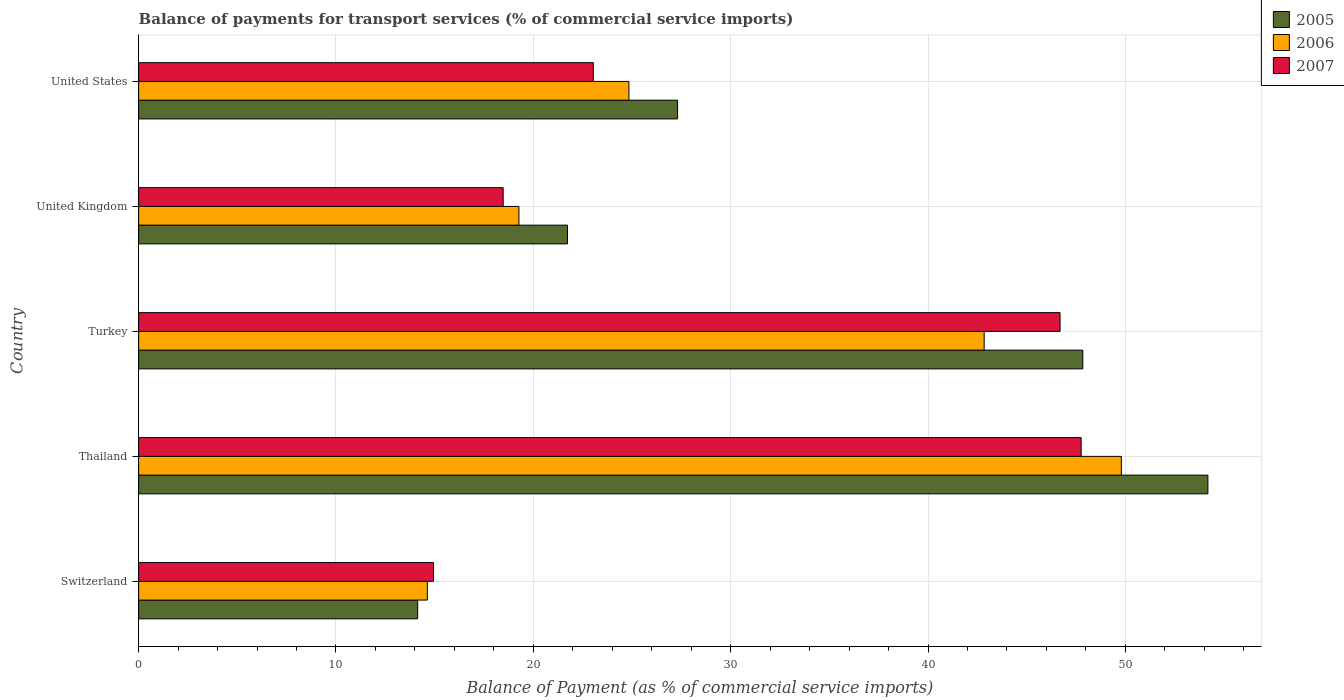How many different coloured bars are there?
Ensure brevity in your answer.  3. How many groups of bars are there?
Offer a very short reply. 5. Are the number of bars per tick equal to the number of legend labels?
Give a very brief answer. Yes. How many bars are there on the 2nd tick from the top?
Provide a succinct answer. 3. What is the label of the 4th group of bars from the top?
Ensure brevity in your answer.  Thailand. In how many cases, is the number of bars for a given country not equal to the number of legend labels?
Provide a short and direct response. 0. What is the balance of payments for transport services in 2005 in United States?
Your answer should be compact. 27.31. Across all countries, what is the maximum balance of payments for transport services in 2005?
Ensure brevity in your answer.  54.18. Across all countries, what is the minimum balance of payments for transport services in 2006?
Ensure brevity in your answer.  14.63. In which country was the balance of payments for transport services in 2006 maximum?
Provide a succinct answer. Thailand. In which country was the balance of payments for transport services in 2006 minimum?
Provide a short and direct response. Switzerland. What is the total balance of payments for transport services in 2005 in the graph?
Ensure brevity in your answer.  165.2. What is the difference between the balance of payments for transport services in 2005 in Thailand and that in United States?
Your answer should be compact. 26.87. What is the difference between the balance of payments for transport services in 2005 in United Kingdom and the balance of payments for transport services in 2007 in United States?
Your response must be concise. -1.31. What is the average balance of payments for transport services in 2005 per country?
Offer a terse response. 33.04. What is the difference between the balance of payments for transport services in 2005 and balance of payments for transport services in 2007 in United Kingdom?
Keep it short and to the point. 3.26. What is the ratio of the balance of payments for transport services in 2005 in Switzerland to that in United States?
Your answer should be compact. 0.52. Is the balance of payments for transport services in 2007 in Switzerland less than that in Thailand?
Give a very brief answer. Yes. What is the difference between the highest and the second highest balance of payments for transport services in 2006?
Give a very brief answer. 6.95. What is the difference between the highest and the lowest balance of payments for transport services in 2005?
Your answer should be very brief. 40.04. In how many countries, is the balance of payments for transport services in 2006 greater than the average balance of payments for transport services in 2006 taken over all countries?
Offer a very short reply. 2. Is the sum of the balance of payments for transport services in 2006 in Thailand and United States greater than the maximum balance of payments for transport services in 2005 across all countries?
Provide a short and direct response. Yes. What does the 2nd bar from the bottom in Turkey represents?
Provide a short and direct response. 2006. Is it the case that in every country, the sum of the balance of payments for transport services in 2006 and balance of payments for transport services in 2005 is greater than the balance of payments for transport services in 2007?
Make the answer very short. Yes. How many bars are there?
Offer a very short reply. 15. Are all the bars in the graph horizontal?
Offer a terse response. Yes. How many countries are there in the graph?
Ensure brevity in your answer.  5. What is the difference between two consecutive major ticks on the X-axis?
Offer a terse response. 10. Are the values on the major ticks of X-axis written in scientific E-notation?
Keep it short and to the point. No. Where does the legend appear in the graph?
Provide a short and direct response. Top right. How are the legend labels stacked?
Your answer should be very brief. Vertical. What is the title of the graph?
Give a very brief answer. Balance of payments for transport services (% of commercial service imports). What is the label or title of the X-axis?
Your answer should be compact. Balance of Payment (as % of commercial service imports). What is the Balance of Payment (as % of commercial service imports) of 2005 in Switzerland?
Give a very brief answer. 14.14. What is the Balance of Payment (as % of commercial service imports) in 2006 in Switzerland?
Your answer should be very brief. 14.63. What is the Balance of Payment (as % of commercial service imports) in 2007 in Switzerland?
Your answer should be very brief. 14.94. What is the Balance of Payment (as % of commercial service imports) in 2005 in Thailand?
Make the answer very short. 54.18. What is the Balance of Payment (as % of commercial service imports) of 2006 in Thailand?
Provide a short and direct response. 49.79. What is the Balance of Payment (as % of commercial service imports) in 2007 in Thailand?
Provide a short and direct response. 47.76. What is the Balance of Payment (as % of commercial service imports) of 2005 in Turkey?
Your answer should be very brief. 47.84. What is the Balance of Payment (as % of commercial service imports) of 2006 in Turkey?
Your answer should be very brief. 42.84. What is the Balance of Payment (as % of commercial service imports) of 2007 in Turkey?
Keep it short and to the point. 46.69. What is the Balance of Payment (as % of commercial service imports) in 2005 in United Kingdom?
Your answer should be compact. 21.73. What is the Balance of Payment (as % of commercial service imports) of 2006 in United Kingdom?
Your response must be concise. 19.27. What is the Balance of Payment (as % of commercial service imports) of 2007 in United Kingdom?
Your answer should be very brief. 18.47. What is the Balance of Payment (as % of commercial service imports) of 2005 in United States?
Keep it short and to the point. 27.31. What is the Balance of Payment (as % of commercial service imports) of 2006 in United States?
Provide a succinct answer. 24.84. What is the Balance of Payment (as % of commercial service imports) of 2007 in United States?
Ensure brevity in your answer.  23.04. Across all countries, what is the maximum Balance of Payment (as % of commercial service imports) in 2005?
Your answer should be compact. 54.18. Across all countries, what is the maximum Balance of Payment (as % of commercial service imports) of 2006?
Offer a terse response. 49.79. Across all countries, what is the maximum Balance of Payment (as % of commercial service imports) in 2007?
Keep it short and to the point. 47.76. Across all countries, what is the minimum Balance of Payment (as % of commercial service imports) of 2005?
Offer a very short reply. 14.14. Across all countries, what is the minimum Balance of Payment (as % of commercial service imports) of 2006?
Your response must be concise. 14.63. Across all countries, what is the minimum Balance of Payment (as % of commercial service imports) of 2007?
Your answer should be very brief. 14.94. What is the total Balance of Payment (as % of commercial service imports) in 2005 in the graph?
Your answer should be very brief. 165.2. What is the total Balance of Payment (as % of commercial service imports) of 2006 in the graph?
Provide a short and direct response. 151.38. What is the total Balance of Payment (as % of commercial service imports) in 2007 in the graph?
Your response must be concise. 150.9. What is the difference between the Balance of Payment (as % of commercial service imports) in 2005 in Switzerland and that in Thailand?
Provide a short and direct response. -40.04. What is the difference between the Balance of Payment (as % of commercial service imports) of 2006 in Switzerland and that in Thailand?
Keep it short and to the point. -35.17. What is the difference between the Balance of Payment (as % of commercial service imports) in 2007 in Switzerland and that in Thailand?
Ensure brevity in your answer.  -32.82. What is the difference between the Balance of Payment (as % of commercial service imports) of 2005 in Switzerland and that in Turkey?
Offer a terse response. -33.7. What is the difference between the Balance of Payment (as % of commercial service imports) in 2006 in Switzerland and that in Turkey?
Provide a short and direct response. -28.21. What is the difference between the Balance of Payment (as % of commercial service imports) in 2007 in Switzerland and that in Turkey?
Give a very brief answer. -31.75. What is the difference between the Balance of Payment (as % of commercial service imports) of 2005 in Switzerland and that in United Kingdom?
Ensure brevity in your answer.  -7.59. What is the difference between the Balance of Payment (as % of commercial service imports) of 2006 in Switzerland and that in United Kingdom?
Offer a very short reply. -4.64. What is the difference between the Balance of Payment (as % of commercial service imports) in 2007 in Switzerland and that in United Kingdom?
Your response must be concise. -3.53. What is the difference between the Balance of Payment (as % of commercial service imports) of 2005 in Switzerland and that in United States?
Offer a very short reply. -13.17. What is the difference between the Balance of Payment (as % of commercial service imports) of 2006 in Switzerland and that in United States?
Your answer should be very brief. -10.21. What is the difference between the Balance of Payment (as % of commercial service imports) of 2007 in Switzerland and that in United States?
Provide a succinct answer. -8.1. What is the difference between the Balance of Payment (as % of commercial service imports) of 2005 in Thailand and that in Turkey?
Ensure brevity in your answer.  6.34. What is the difference between the Balance of Payment (as % of commercial service imports) in 2006 in Thailand and that in Turkey?
Provide a short and direct response. 6.95. What is the difference between the Balance of Payment (as % of commercial service imports) of 2007 in Thailand and that in Turkey?
Make the answer very short. 1.07. What is the difference between the Balance of Payment (as % of commercial service imports) of 2005 in Thailand and that in United Kingdom?
Your answer should be compact. 32.45. What is the difference between the Balance of Payment (as % of commercial service imports) of 2006 in Thailand and that in United Kingdom?
Offer a terse response. 30.52. What is the difference between the Balance of Payment (as % of commercial service imports) of 2007 in Thailand and that in United Kingdom?
Keep it short and to the point. 29.29. What is the difference between the Balance of Payment (as % of commercial service imports) in 2005 in Thailand and that in United States?
Provide a succinct answer. 26.87. What is the difference between the Balance of Payment (as % of commercial service imports) in 2006 in Thailand and that in United States?
Give a very brief answer. 24.95. What is the difference between the Balance of Payment (as % of commercial service imports) in 2007 in Thailand and that in United States?
Provide a succinct answer. 24.72. What is the difference between the Balance of Payment (as % of commercial service imports) in 2005 in Turkey and that in United Kingdom?
Your answer should be compact. 26.11. What is the difference between the Balance of Payment (as % of commercial service imports) in 2006 in Turkey and that in United Kingdom?
Offer a terse response. 23.57. What is the difference between the Balance of Payment (as % of commercial service imports) of 2007 in Turkey and that in United Kingdom?
Offer a very short reply. 28.22. What is the difference between the Balance of Payment (as % of commercial service imports) in 2005 in Turkey and that in United States?
Ensure brevity in your answer.  20.53. What is the difference between the Balance of Payment (as % of commercial service imports) of 2006 in Turkey and that in United States?
Provide a short and direct response. 18. What is the difference between the Balance of Payment (as % of commercial service imports) in 2007 in Turkey and that in United States?
Make the answer very short. 23.65. What is the difference between the Balance of Payment (as % of commercial service imports) of 2005 in United Kingdom and that in United States?
Your answer should be very brief. -5.58. What is the difference between the Balance of Payment (as % of commercial service imports) in 2006 in United Kingdom and that in United States?
Give a very brief answer. -5.57. What is the difference between the Balance of Payment (as % of commercial service imports) of 2007 in United Kingdom and that in United States?
Offer a terse response. -4.57. What is the difference between the Balance of Payment (as % of commercial service imports) in 2005 in Switzerland and the Balance of Payment (as % of commercial service imports) in 2006 in Thailand?
Your answer should be very brief. -35.66. What is the difference between the Balance of Payment (as % of commercial service imports) of 2005 in Switzerland and the Balance of Payment (as % of commercial service imports) of 2007 in Thailand?
Offer a terse response. -33.62. What is the difference between the Balance of Payment (as % of commercial service imports) in 2006 in Switzerland and the Balance of Payment (as % of commercial service imports) in 2007 in Thailand?
Provide a succinct answer. -33.13. What is the difference between the Balance of Payment (as % of commercial service imports) in 2005 in Switzerland and the Balance of Payment (as % of commercial service imports) in 2006 in Turkey?
Give a very brief answer. -28.7. What is the difference between the Balance of Payment (as % of commercial service imports) in 2005 in Switzerland and the Balance of Payment (as % of commercial service imports) in 2007 in Turkey?
Make the answer very short. -32.55. What is the difference between the Balance of Payment (as % of commercial service imports) of 2006 in Switzerland and the Balance of Payment (as % of commercial service imports) of 2007 in Turkey?
Your answer should be compact. -32.06. What is the difference between the Balance of Payment (as % of commercial service imports) of 2005 in Switzerland and the Balance of Payment (as % of commercial service imports) of 2006 in United Kingdom?
Ensure brevity in your answer.  -5.13. What is the difference between the Balance of Payment (as % of commercial service imports) in 2005 in Switzerland and the Balance of Payment (as % of commercial service imports) in 2007 in United Kingdom?
Provide a short and direct response. -4.33. What is the difference between the Balance of Payment (as % of commercial service imports) in 2006 in Switzerland and the Balance of Payment (as % of commercial service imports) in 2007 in United Kingdom?
Offer a terse response. -3.84. What is the difference between the Balance of Payment (as % of commercial service imports) of 2005 in Switzerland and the Balance of Payment (as % of commercial service imports) of 2006 in United States?
Ensure brevity in your answer.  -10.7. What is the difference between the Balance of Payment (as % of commercial service imports) in 2005 in Switzerland and the Balance of Payment (as % of commercial service imports) in 2007 in United States?
Provide a succinct answer. -8.9. What is the difference between the Balance of Payment (as % of commercial service imports) of 2006 in Switzerland and the Balance of Payment (as % of commercial service imports) of 2007 in United States?
Your answer should be compact. -8.41. What is the difference between the Balance of Payment (as % of commercial service imports) of 2005 in Thailand and the Balance of Payment (as % of commercial service imports) of 2006 in Turkey?
Provide a succinct answer. 11.34. What is the difference between the Balance of Payment (as % of commercial service imports) in 2005 in Thailand and the Balance of Payment (as % of commercial service imports) in 2007 in Turkey?
Your response must be concise. 7.49. What is the difference between the Balance of Payment (as % of commercial service imports) of 2006 in Thailand and the Balance of Payment (as % of commercial service imports) of 2007 in Turkey?
Your answer should be compact. 3.11. What is the difference between the Balance of Payment (as % of commercial service imports) of 2005 in Thailand and the Balance of Payment (as % of commercial service imports) of 2006 in United Kingdom?
Give a very brief answer. 34.91. What is the difference between the Balance of Payment (as % of commercial service imports) in 2005 in Thailand and the Balance of Payment (as % of commercial service imports) in 2007 in United Kingdom?
Ensure brevity in your answer.  35.71. What is the difference between the Balance of Payment (as % of commercial service imports) in 2006 in Thailand and the Balance of Payment (as % of commercial service imports) in 2007 in United Kingdom?
Your response must be concise. 31.32. What is the difference between the Balance of Payment (as % of commercial service imports) of 2005 in Thailand and the Balance of Payment (as % of commercial service imports) of 2006 in United States?
Provide a short and direct response. 29.34. What is the difference between the Balance of Payment (as % of commercial service imports) in 2005 in Thailand and the Balance of Payment (as % of commercial service imports) in 2007 in United States?
Provide a succinct answer. 31.14. What is the difference between the Balance of Payment (as % of commercial service imports) of 2006 in Thailand and the Balance of Payment (as % of commercial service imports) of 2007 in United States?
Ensure brevity in your answer.  26.76. What is the difference between the Balance of Payment (as % of commercial service imports) of 2005 in Turkey and the Balance of Payment (as % of commercial service imports) of 2006 in United Kingdom?
Your response must be concise. 28.57. What is the difference between the Balance of Payment (as % of commercial service imports) in 2005 in Turkey and the Balance of Payment (as % of commercial service imports) in 2007 in United Kingdom?
Give a very brief answer. 29.37. What is the difference between the Balance of Payment (as % of commercial service imports) in 2006 in Turkey and the Balance of Payment (as % of commercial service imports) in 2007 in United Kingdom?
Offer a terse response. 24.37. What is the difference between the Balance of Payment (as % of commercial service imports) in 2005 in Turkey and the Balance of Payment (as % of commercial service imports) in 2006 in United States?
Ensure brevity in your answer.  23. What is the difference between the Balance of Payment (as % of commercial service imports) of 2005 in Turkey and the Balance of Payment (as % of commercial service imports) of 2007 in United States?
Keep it short and to the point. 24.8. What is the difference between the Balance of Payment (as % of commercial service imports) in 2006 in Turkey and the Balance of Payment (as % of commercial service imports) in 2007 in United States?
Offer a terse response. 19.8. What is the difference between the Balance of Payment (as % of commercial service imports) in 2005 in United Kingdom and the Balance of Payment (as % of commercial service imports) in 2006 in United States?
Your response must be concise. -3.11. What is the difference between the Balance of Payment (as % of commercial service imports) in 2005 in United Kingdom and the Balance of Payment (as % of commercial service imports) in 2007 in United States?
Your answer should be compact. -1.31. What is the difference between the Balance of Payment (as % of commercial service imports) in 2006 in United Kingdom and the Balance of Payment (as % of commercial service imports) in 2007 in United States?
Make the answer very short. -3.77. What is the average Balance of Payment (as % of commercial service imports) in 2005 per country?
Offer a terse response. 33.04. What is the average Balance of Payment (as % of commercial service imports) in 2006 per country?
Your answer should be very brief. 30.28. What is the average Balance of Payment (as % of commercial service imports) in 2007 per country?
Your answer should be very brief. 30.18. What is the difference between the Balance of Payment (as % of commercial service imports) in 2005 and Balance of Payment (as % of commercial service imports) in 2006 in Switzerland?
Provide a short and direct response. -0.49. What is the difference between the Balance of Payment (as % of commercial service imports) in 2005 and Balance of Payment (as % of commercial service imports) in 2007 in Switzerland?
Provide a short and direct response. -0.8. What is the difference between the Balance of Payment (as % of commercial service imports) of 2006 and Balance of Payment (as % of commercial service imports) of 2007 in Switzerland?
Offer a very short reply. -0.31. What is the difference between the Balance of Payment (as % of commercial service imports) in 2005 and Balance of Payment (as % of commercial service imports) in 2006 in Thailand?
Your answer should be compact. 4.39. What is the difference between the Balance of Payment (as % of commercial service imports) in 2005 and Balance of Payment (as % of commercial service imports) in 2007 in Thailand?
Offer a very short reply. 6.42. What is the difference between the Balance of Payment (as % of commercial service imports) of 2006 and Balance of Payment (as % of commercial service imports) of 2007 in Thailand?
Offer a terse response. 2.04. What is the difference between the Balance of Payment (as % of commercial service imports) in 2005 and Balance of Payment (as % of commercial service imports) in 2006 in Turkey?
Ensure brevity in your answer.  5. What is the difference between the Balance of Payment (as % of commercial service imports) of 2005 and Balance of Payment (as % of commercial service imports) of 2007 in Turkey?
Your answer should be very brief. 1.15. What is the difference between the Balance of Payment (as % of commercial service imports) of 2006 and Balance of Payment (as % of commercial service imports) of 2007 in Turkey?
Offer a very short reply. -3.85. What is the difference between the Balance of Payment (as % of commercial service imports) in 2005 and Balance of Payment (as % of commercial service imports) in 2006 in United Kingdom?
Provide a succinct answer. 2.46. What is the difference between the Balance of Payment (as % of commercial service imports) of 2005 and Balance of Payment (as % of commercial service imports) of 2007 in United Kingdom?
Offer a very short reply. 3.26. What is the difference between the Balance of Payment (as % of commercial service imports) of 2006 and Balance of Payment (as % of commercial service imports) of 2007 in United Kingdom?
Make the answer very short. 0.8. What is the difference between the Balance of Payment (as % of commercial service imports) in 2005 and Balance of Payment (as % of commercial service imports) in 2006 in United States?
Your response must be concise. 2.47. What is the difference between the Balance of Payment (as % of commercial service imports) in 2005 and Balance of Payment (as % of commercial service imports) in 2007 in United States?
Ensure brevity in your answer.  4.27. What is the difference between the Balance of Payment (as % of commercial service imports) of 2006 and Balance of Payment (as % of commercial service imports) of 2007 in United States?
Your response must be concise. 1.8. What is the ratio of the Balance of Payment (as % of commercial service imports) in 2005 in Switzerland to that in Thailand?
Ensure brevity in your answer.  0.26. What is the ratio of the Balance of Payment (as % of commercial service imports) of 2006 in Switzerland to that in Thailand?
Your response must be concise. 0.29. What is the ratio of the Balance of Payment (as % of commercial service imports) in 2007 in Switzerland to that in Thailand?
Your answer should be compact. 0.31. What is the ratio of the Balance of Payment (as % of commercial service imports) of 2005 in Switzerland to that in Turkey?
Offer a terse response. 0.3. What is the ratio of the Balance of Payment (as % of commercial service imports) of 2006 in Switzerland to that in Turkey?
Your answer should be compact. 0.34. What is the ratio of the Balance of Payment (as % of commercial service imports) in 2007 in Switzerland to that in Turkey?
Offer a very short reply. 0.32. What is the ratio of the Balance of Payment (as % of commercial service imports) in 2005 in Switzerland to that in United Kingdom?
Make the answer very short. 0.65. What is the ratio of the Balance of Payment (as % of commercial service imports) of 2006 in Switzerland to that in United Kingdom?
Your response must be concise. 0.76. What is the ratio of the Balance of Payment (as % of commercial service imports) of 2007 in Switzerland to that in United Kingdom?
Keep it short and to the point. 0.81. What is the ratio of the Balance of Payment (as % of commercial service imports) of 2005 in Switzerland to that in United States?
Provide a short and direct response. 0.52. What is the ratio of the Balance of Payment (as % of commercial service imports) in 2006 in Switzerland to that in United States?
Provide a short and direct response. 0.59. What is the ratio of the Balance of Payment (as % of commercial service imports) of 2007 in Switzerland to that in United States?
Give a very brief answer. 0.65. What is the ratio of the Balance of Payment (as % of commercial service imports) of 2005 in Thailand to that in Turkey?
Ensure brevity in your answer.  1.13. What is the ratio of the Balance of Payment (as % of commercial service imports) of 2006 in Thailand to that in Turkey?
Keep it short and to the point. 1.16. What is the ratio of the Balance of Payment (as % of commercial service imports) in 2007 in Thailand to that in Turkey?
Make the answer very short. 1.02. What is the ratio of the Balance of Payment (as % of commercial service imports) of 2005 in Thailand to that in United Kingdom?
Offer a terse response. 2.49. What is the ratio of the Balance of Payment (as % of commercial service imports) of 2006 in Thailand to that in United Kingdom?
Your answer should be very brief. 2.58. What is the ratio of the Balance of Payment (as % of commercial service imports) of 2007 in Thailand to that in United Kingdom?
Offer a very short reply. 2.59. What is the ratio of the Balance of Payment (as % of commercial service imports) of 2005 in Thailand to that in United States?
Your response must be concise. 1.98. What is the ratio of the Balance of Payment (as % of commercial service imports) in 2006 in Thailand to that in United States?
Provide a succinct answer. 2. What is the ratio of the Balance of Payment (as % of commercial service imports) of 2007 in Thailand to that in United States?
Make the answer very short. 2.07. What is the ratio of the Balance of Payment (as % of commercial service imports) of 2005 in Turkey to that in United Kingdom?
Ensure brevity in your answer.  2.2. What is the ratio of the Balance of Payment (as % of commercial service imports) in 2006 in Turkey to that in United Kingdom?
Your answer should be compact. 2.22. What is the ratio of the Balance of Payment (as % of commercial service imports) in 2007 in Turkey to that in United Kingdom?
Offer a terse response. 2.53. What is the ratio of the Balance of Payment (as % of commercial service imports) in 2005 in Turkey to that in United States?
Make the answer very short. 1.75. What is the ratio of the Balance of Payment (as % of commercial service imports) of 2006 in Turkey to that in United States?
Make the answer very short. 1.72. What is the ratio of the Balance of Payment (as % of commercial service imports) of 2007 in Turkey to that in United States?
Ensure brevity in your answer.  2.03. What is the ratio of the Balance of Payment (as % of commercial service imports) in 2005 in United Kingdom to that in United States?
Ensure brevity in your answer.  0.8. What is the ratio of the Balance of Payment (as % of commercial service imports) of 2006 in United Kingdom to that in United States?
Ensure brevity in your answer.  0.78. What is the ratio of the Balance of Payment (as % of commercial service imports) in 2007 in United Kingdom to that in United States?
Ensure brevity in your answer.  0.8. What is the difference between the highest and the second highest Balance of Payment (as % of commercial service imports) of 2005?
Provide a succinct answer. 6.34. What is the difference between the highest and the second highest Balance of Payment (as % of commercial service imports) in 2006?
Ensure brevity in your answer.  6.95. What is the difference between the highest and the second highest Balance of Payment (as % of commercial service imports) in 2007?
Give a very brief answer. 1.07. What is the difference between the highest and the lowest Balance of Payment (as % of commercial service imports) in 2005?
Offer a terse response. 40.04. What is the difference between the highest and the lowest Balance of Payment (as % of commercial service imports) in 2006?
Offer a very short reply. 35.17. What is the difference between the highest and the lowest Balance of Payment (as % of commercial service imports) in 2007?
Make the answer very short. 32.82. 